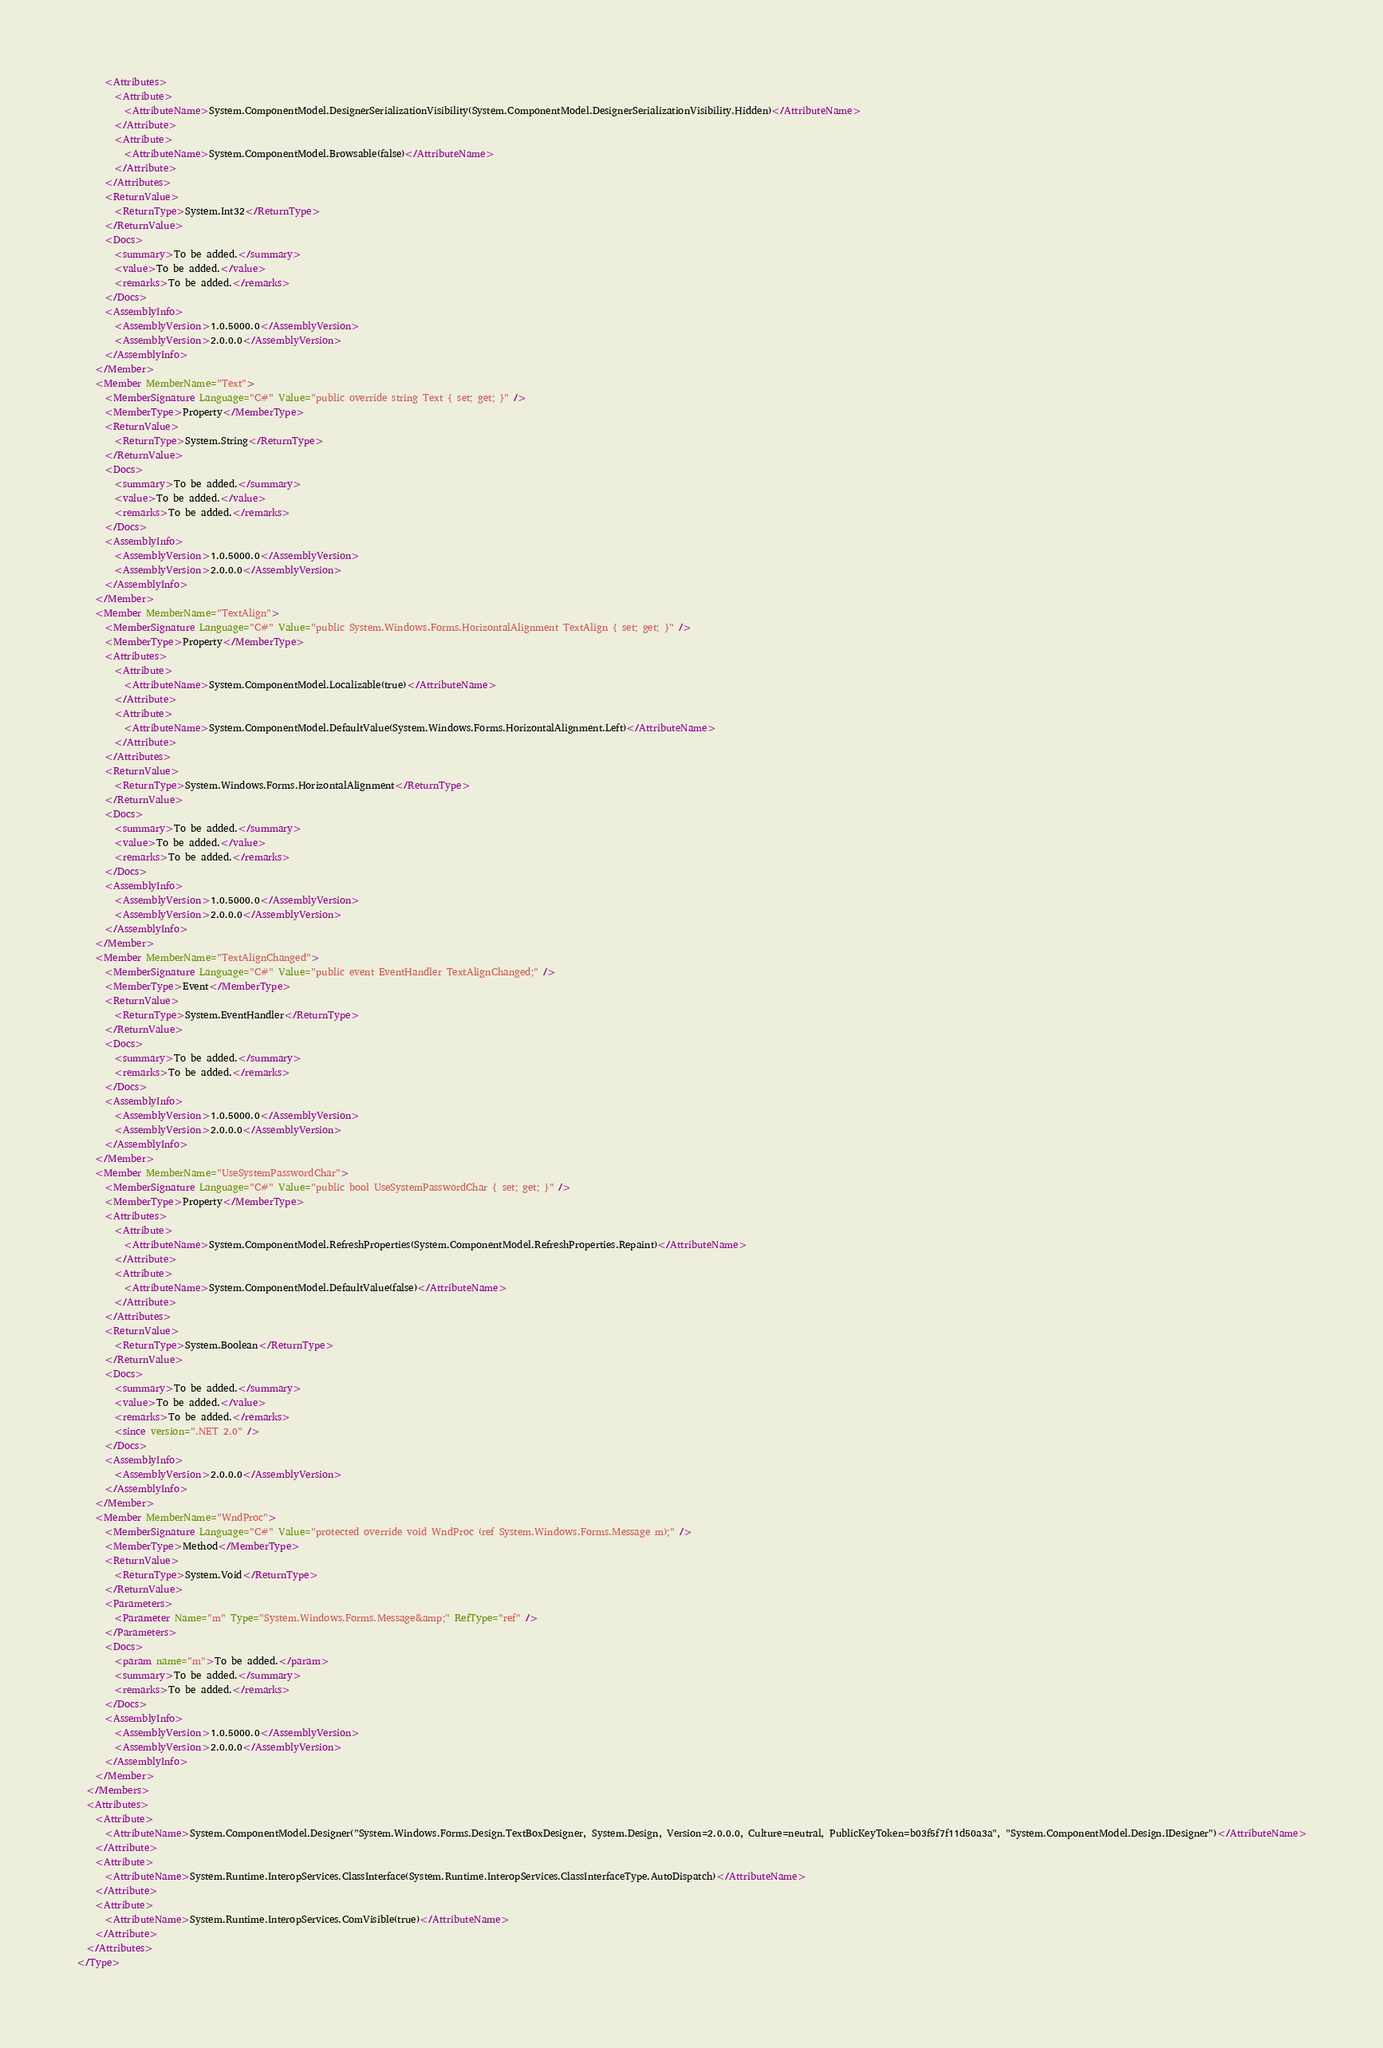<code> <loc_0><loc_0><loc_500><loc_500><_XML_>      <Attributes>
        <Attribute>
          <AttributeName>System.ComponentModel.DesignerSerializationVisibility(System.ComponentModel.DesignerSerializationVisibility.Hidden)</AttributeName>
        </Attribute>
        <Attribute>
          <AttributeName>System.ComponentModel.Browsable(false)</AttributeName>
        </Attribute>
      </Attributes>
      <ReturnValue>
        <ReturnType>System.Int32</ReturnType>
      </ReturnValue>
      <Docs>
        <summary>To be added.</summary>
        <value>To be added.</value>
        <remarks>To be added.</remarks>
      </Docs>
      <AssemblyInfo>
        <AssemblyVersion>1.0.5000.0</AssemblyVersion>
        <AssemblyVersion>2.0.0.0</AssemblyVersion>
      </AssemblyInfo>
    </Member>
    <Member MemberName="Text">
      <MemberSignature Language="C#" Value="public override string Text { set; get; }" />
      <MemberType>Property</MemberType>
      <ReturnValue>
        <ReturnType>System.String</ReturnType>
      </ReturnValue>
      <Docs>
        <summary>To be added.</summary>
        <value>To be added.</value>
        <remarks>To be added.</remarks>
      </Docs>
      <AssemblyInfo>
        <AssemblyVersion>1.0.5000.0</AssemblyVersion>
        <AssemblyVersion>2.0.0.0</AssemblyVersion>
      </AssemblyInfo>
    </Member>
    <Member MemberName="TextAlign">
      <MemberSignature Language="C#" Value="public System.Windows.Forms.HorizontalAlignment TextAlign { set; get; }" />
      <MemberType>Property</MemberType>
      <Attributes>
        <Attribute>
          <AttributeName>System.ComponentModel.Localizable(true)</AttributeName>
        </Attribute>
        <Attribute>
          <AttributeName>System.ComponentModel.DefaultValue(System.Windows.Forms.HorizontalAlignment.Left)</AttributeName>
        </Attribute>
      </Attributes>
      <ReturnValue>
        <ReturnType>System.Windows.Forms.HorizontalAlignment</ReturnType>
      </ReturnValue>
      <Docs>
        <summary>To be added.</summary>
        <value>To be added.</value>
        <remarks>To be added.</remarks>
      </Docs>
      <AssemblyInfo>
        <AssemblyVersion>1.0.5000.0</AssemblyVersion>
        <AssemblyVersion>2.0.0.0</AssemblyVersion>
      </AssemblyInfo>
    </Member>
    <Member MemberName="TextAlignChanged">
      <MemberSignature Language="C#" Value="public event EventHandler TextAlignChanged;" />
      <MemberType>Event</MemberType>
      <ReturnValue>
        <ReturnType>System.EventHandler</ReturnType>
      </ReturnValue>
      <Docs>
        <summary>To be added.</summary>
        <remarks>To be added.</remarks>
      </Docs>
      <AssemblyInfo>
        <AssemblyVersion>1.0.5000.0</AssemblyVersion>
        <AssemblyVersion>2.0.0.0</AssemblyVersion>
      </AssemblyInfo>
    </Member>
    <Member MemberName="UseSystemPasswordChar">
      <MemberSignature Language="C#" Value="public bool UseSystemPasswordChar { set; get; }" />
      <MemberType>Property</MemberType>
      <Attributes>
        <Attribute>
          <AttributeName>System.ComponentModel.RefreshProperties(System.ComponentModel.RefreshProperties.Repaint)</AttributeName>
        </Attribute>
        <Attribute>
          <AttributeName>System.ComponentModel.DefaultValue(false)</AttributeName>
        </Attribute>
      </Attributes>
      <ReturnValue>
        <ReturnType>System.Boolean</ReturnType>
      </ReturnValue>
      <Docs>
        <summary>To be added.</summary>
        <value>To be added.</value>
        <remarks>To be added.</remarks>
        <since version=".NET 2.0" />
      </Docs>
      <AssemblyInfo>
        <AssemblyVersion>2.0.0.0</AssemblyVersion>
      </AssemblyInfo>
    </Member>
    <Member MemberName="WndProc">
      <MemberSignature Language="C#" Value="protected override void WndProc (ref System.Windows.Forms.Message m);" />
      <MemberType>Method</MemberType>
      <ReturnValue>
        <ReturnType>System.Void</ReturnType>
      </ReturnValue>
      <Parameters>
        <Parameter Name="m" Type="System.Windows.Forms.Message&amp;" RefType="ref" />
      </Parameters>
      <Docs>
        <param name="m">To be added.</param>
        <summary>To be added.</summary>
        <remarks>To be added.</remarks>
      </Docs>
      <AssemblyInfo>
        <AssemblyVersion>1.0.5000.0</AssemblyVersion>
        <AssemblyVersion>2.0.0.0</AssemblyVersion>
      </AssemblyInfo>
    </Member>
  </Members>
  <Attributes>
    <Attribute>
      <AttributeName>System.ComponentModel.Designer("System.Windows.Forms.Design.TextBoxDesigner, System.Design, Version=2.0.0.0, Culture=neutral, PublicKeyToken=b03f5f7f11d50a3a", "System.ComponentModel.Design.IDesigner")</AttributeName>
    </Attribute>
    <Attribute>
      <AttributeName>System.Runtime.InteropServices.ClassInterface(System.Runtime.InteropServices.ClassInterfaceType.AutoDispatch)</AttributeName>
    </Attribute>
    <Attribute>
      <AttributeName>System.Runtime.InteropServices.ComVisible(true)</AttributeName>
    </Attribute>
  </Attributes>
</Type>
</code> 